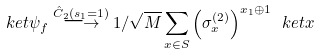Convert formula to latex. <formula><loc_0><loc_0><loc_500><loc_500>\ k e t { \psi _ { f } } \stackrel { \hat { C } _ { 2 } ( s _ { 1 } = 1 ) } { \longrightarrow } 1 / \sqrt { M } \sum _ { x \in S } \left ( \sigma _ { x } ^ { ( 2 ) } \right ) ^ { x _ { 1 } \oplus 1 } \ k e t { x }</formula> 